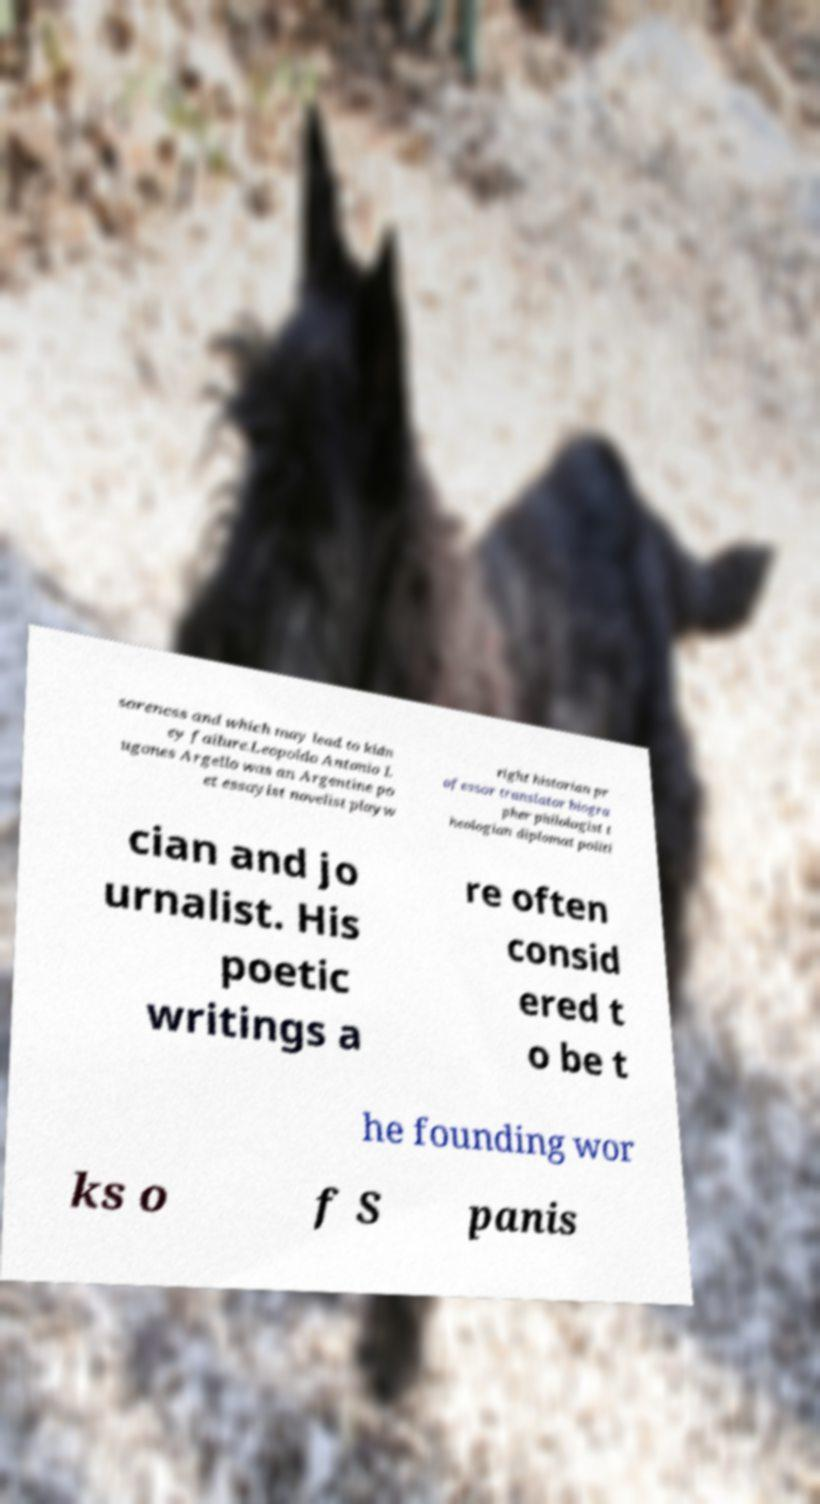Can you accurately transcribe the text from the provided image for me? soreness and which may lead to kidn ey failure.Leopoldo Antonio L ugones Argello was an Argentine po et essayist novelist playw right historian pr ofessor translator biogra pher philologist t heologian diplomat politi cian and jo urnalist. His poetic writings a re often consid ered t o be t he founding wor ks o f S panis 